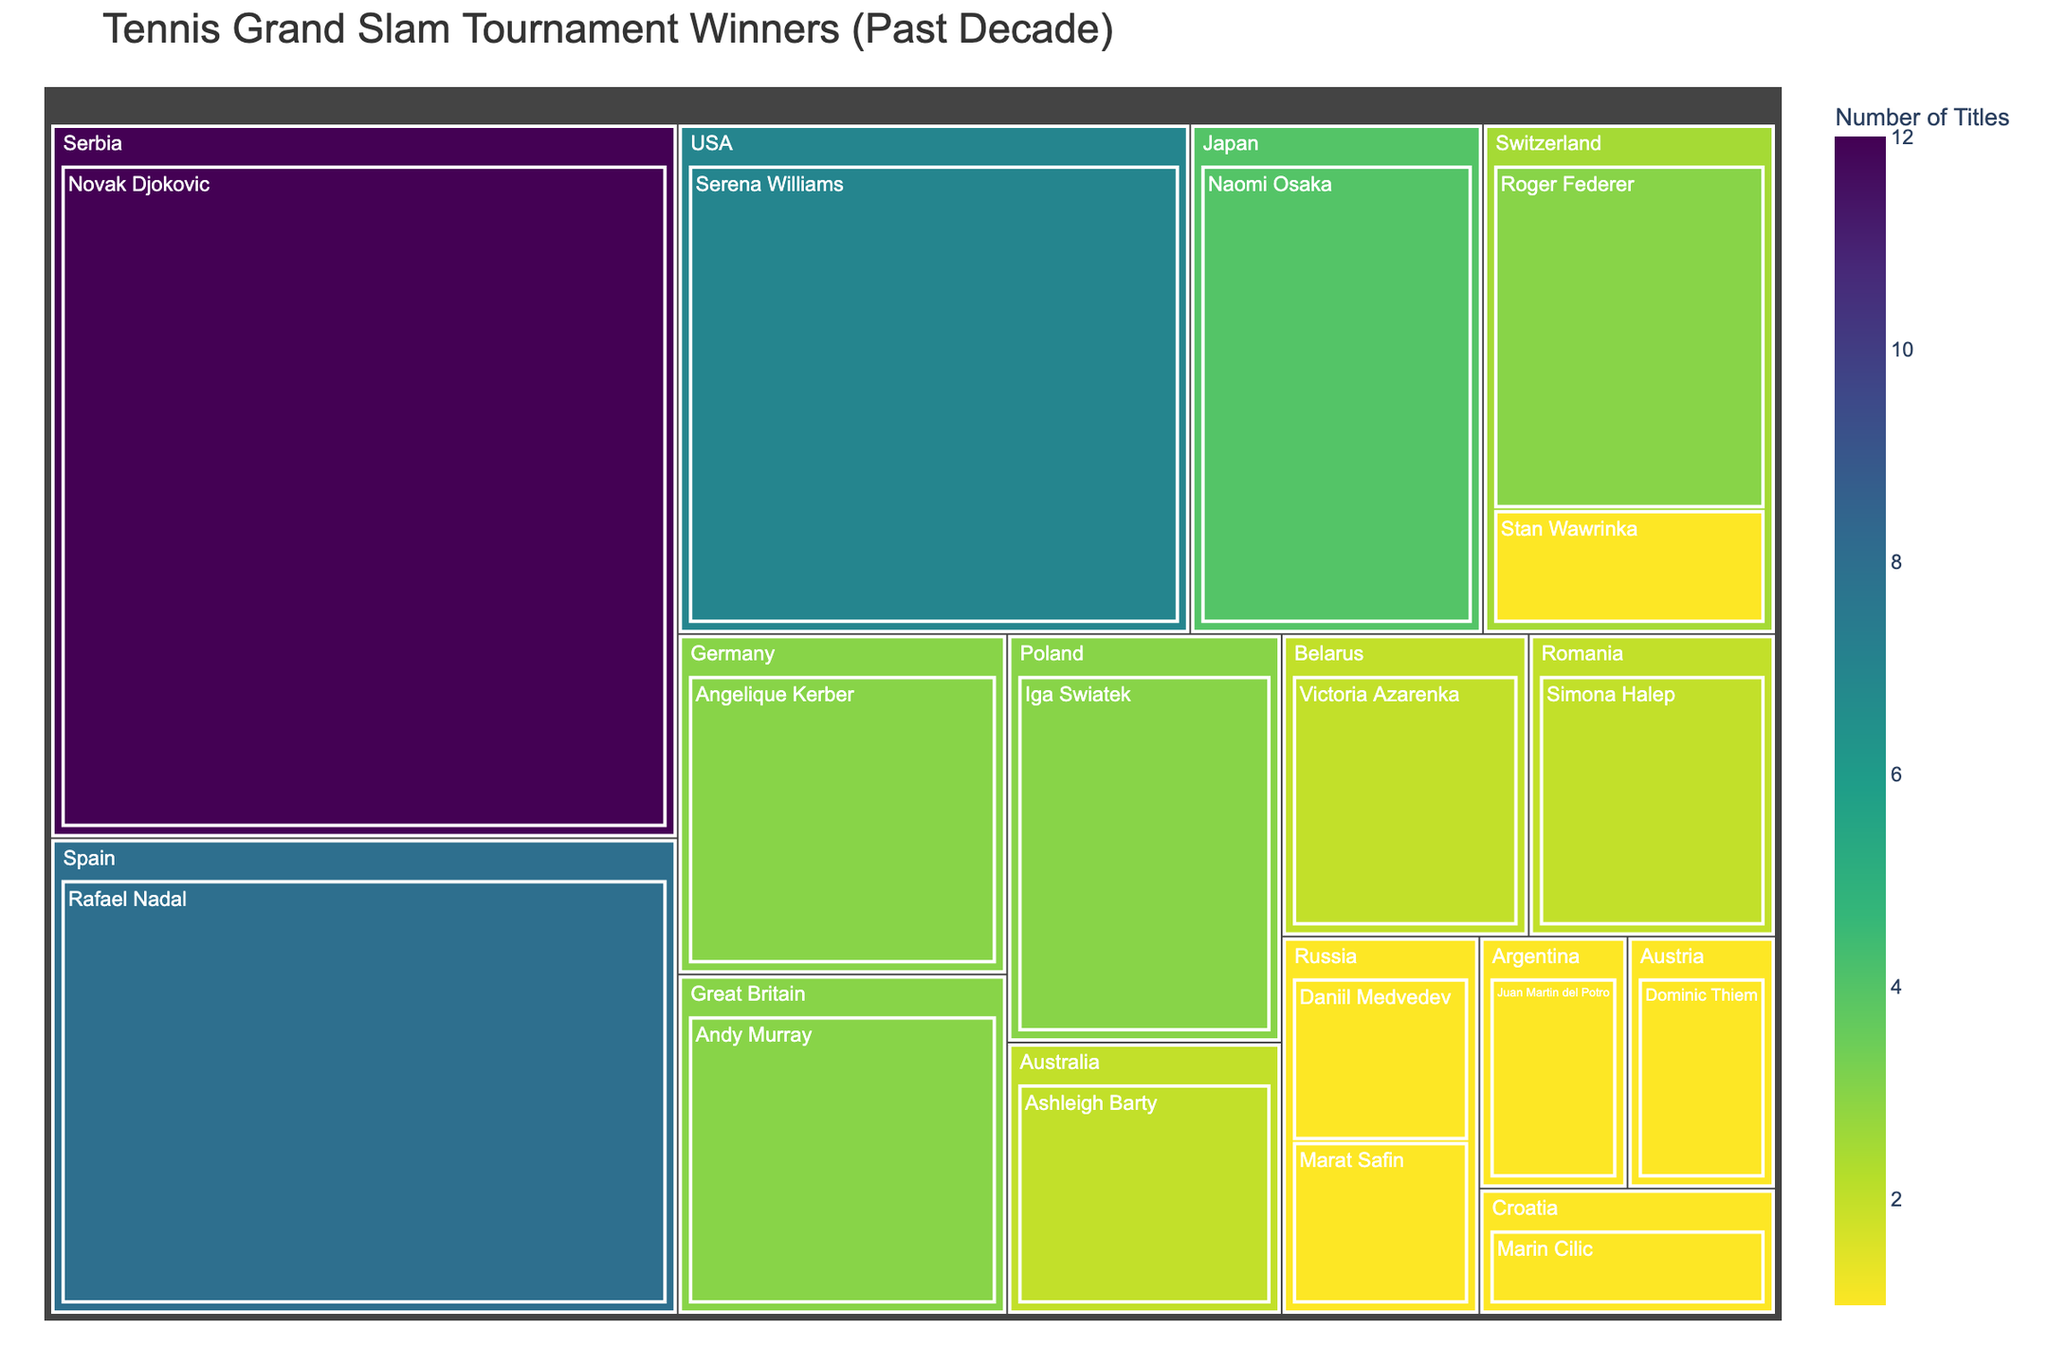Which country has the most Grand Slam titles in the past decade? The treemap shows the distribution of titles by country. Serbia, represented by Novak Djokovic, has the largest section with 12 titles.
Answer: Serbia How many titles have players from Russia collectively won? The treemap reveals two Russian players: Daniil Medvedev and Marat Safin, each with 1 title. Summing these gives a total of 1 + 1 = 2.
Answer: 2 Who are the players from Switzerland, and how many titles do they have together? The treemap shows two Swiss players: Roger Federer with 3 titles and Stan Wawrinka with 1 title. Therefore, together they have 3 + 1 = 4 titles.
Answer: Roger Federer, Stan Wawrinka; 4 Which female player has won the most Grand Slam titles in the past decade? The section for the USA features Serena Williams with 7 titles. As no other female player has more than 7 titles, Serena Williams has the most.
Answer: Serena Williams Compare the number of titles won by players from Spain and Switzerland. Which country has more? Spain is represented by Rafael Nadal with 8 titles, while Switzerland has Roger Federer with 3 titles and Stan Wawrinka with 1 title, totaling 4. Spain has more titles (8 vs. 4).
Answer: Spain How many countries have players who have won at least 3 titles in the past decade? Reviewing the treemap sections, the countries are Serbia, Spain, Great Britain, Germany, Poland, Switzerland, and the USA. Count the sections where players have 3 or more titles, which gives 7 countries.
Answer: 7 What is the combined total of Grand Slam titles won by Rafael Nadal and Novak Djokovic? Rafael Nadal has 8 titles, and Novak Djokovic has 12 titles. Summing these, the combined total is 8 + 12 = 20.
Answer: 20 Which country has more players who have won a Grand Slam title, Russia or Switzerland? From the treemap, Russia has 2 players (Daniil Medvedev and Marat Safin), whereas Switzerland also has 2 players (Roger Federer and Stan Wawrinka). Both countries have an equal number of players with Grand Slam titles.
Answer: Equal Which countries have only one player that has won a Grand Slam title, and who are those players? Countries with only one player shown in the treemap are Austria (Dominic Thiem), Croatia (Marin Cilic), Argentina (Juan Martin del Potro), and Japan (Naomi Osaka).
Answer: Austria: Dominic Thiem; Croatia: Marin Cilic; Argentina: Juan Martin del Potro; Japan: Naomi Osaka 